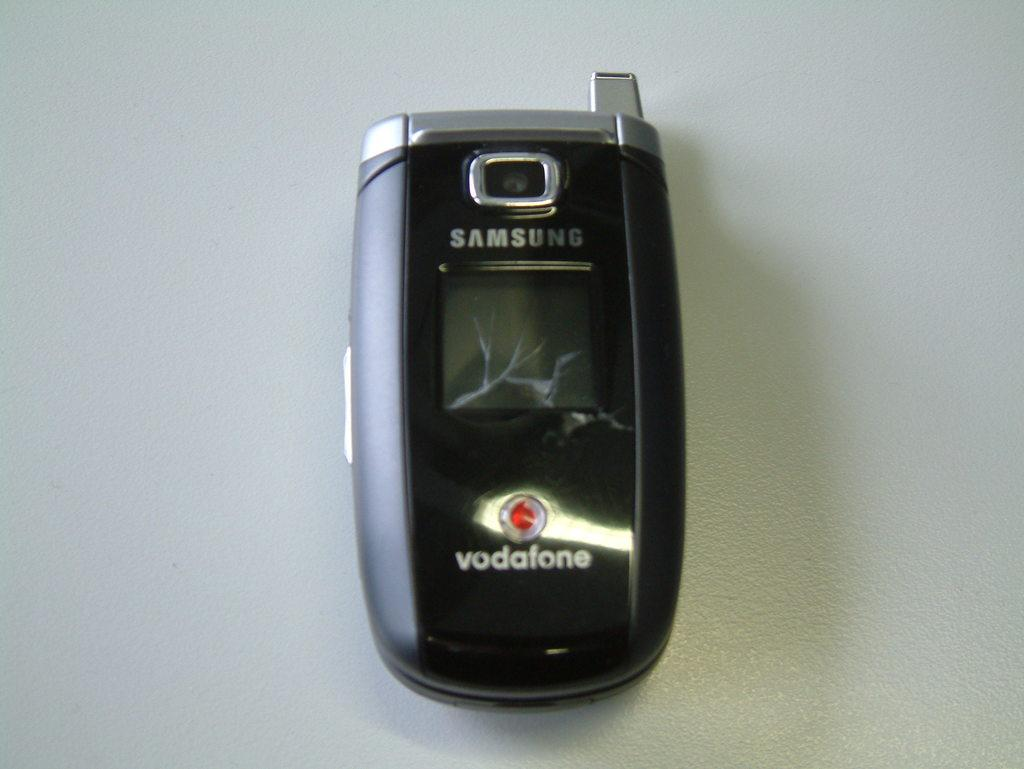<image>
Render a clear and concise summary of the photo. A black Samsung flip cellphone with the words vodatone on the cover 